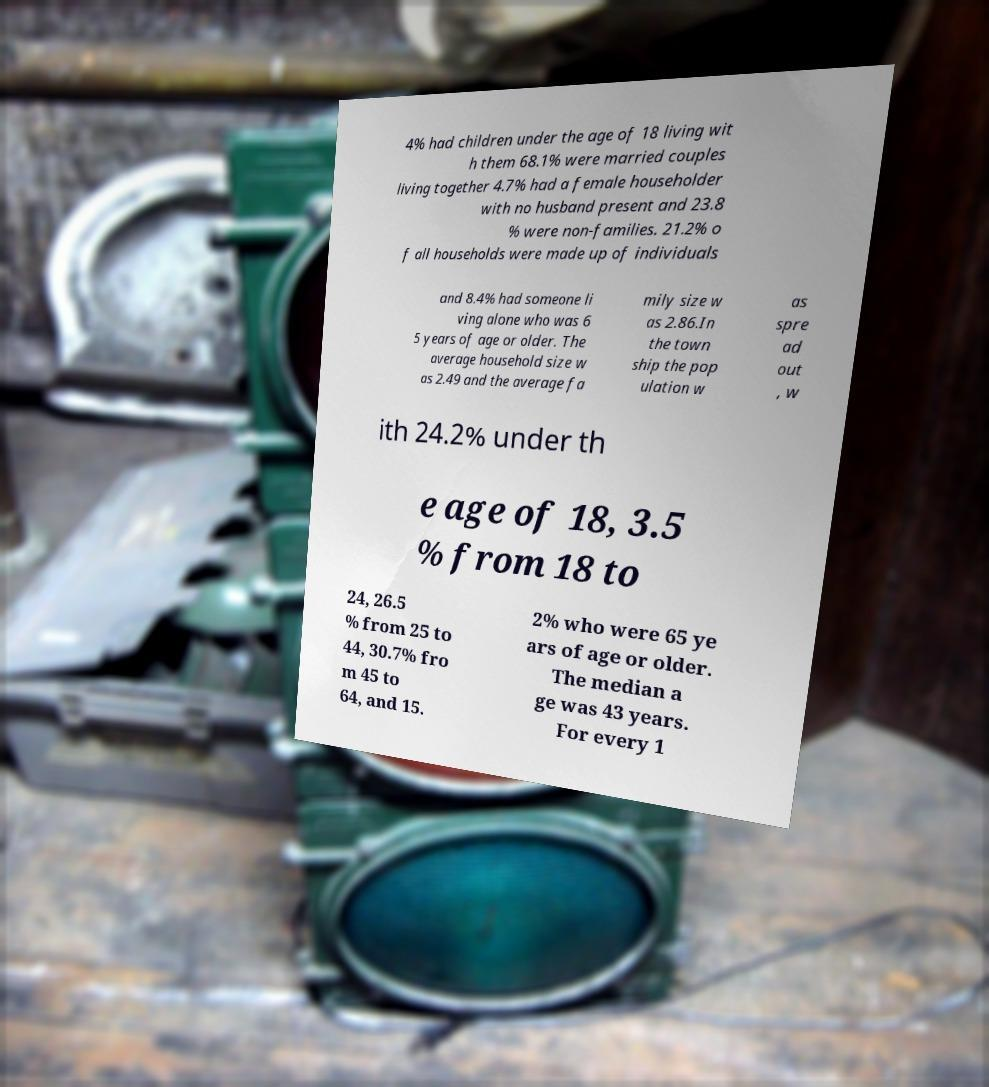There's text embedded in this image that I need extracted. Can you transcribe it verbatim? 4% had children under the age of 18 living wit h them 68.1% were married couples living together 4.7% had a female householder with no husband present and 23.8 % were non-families. 21.2% o f all households were made up of individuals and 8.4% had someone li ving alone who was 6 5 years of age or older. The average household size w as 2.49 and the average fa mily size w as 2.86.In the town ship the pop ulation w as spre ad out , w ith 24.2% under th e age of 18, 3.5 % from 18 to 24, 26.5 % from 25 to 44, 30.7% fro m 45 to 64, and 15. 2% who were 65 ye ars of age or older. The median a ge was 43 years. For every 1 